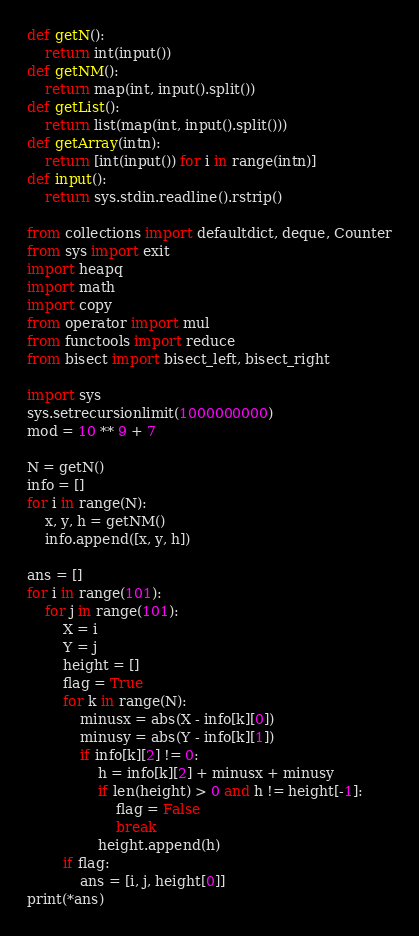<code> <loc_0><loc_0><loc_500><loc_500><_Python_>def getN():
    return int(input())
def getNM():
    return map(int, input().split())
def getList():
    return list(map(int, input().split()))
def getArray(intn):
    return [int(input()) for i in range(intn)]
def input():
    return sys.stdin.readline().rstrip()

from collections import defaultdict, deque, Counter
from sys import exit
import heapq
import math
import copy
from operator import mul
from functools import reduce
from bisect import bisect_left, bisect_right

import sys
sys.setrecursionlimit(1000000000)
mod = 10 ** 9 + 7

N = getN()
info = []
for i in range(N):
    x, y, h = getNM()
    info.append([x, y, h])

ans = []
for i in range(101):
    for j in range(101):
        X = i
        Y = j
        height = []
        flag = True
        for k in range(N):
            minusx = abs(X - info[k][0])
            minusy = abs(Y - info[k][1])
            if info[k][2] != 0:
                h = info[k][2] + minusx + minusy
                if len(height) > 0 and h != height[-1]:
                    flag = False
                    break
                height.append(h)
        if flag:
            ans = [i, j, height[0]]
print(*ans)
</code> 